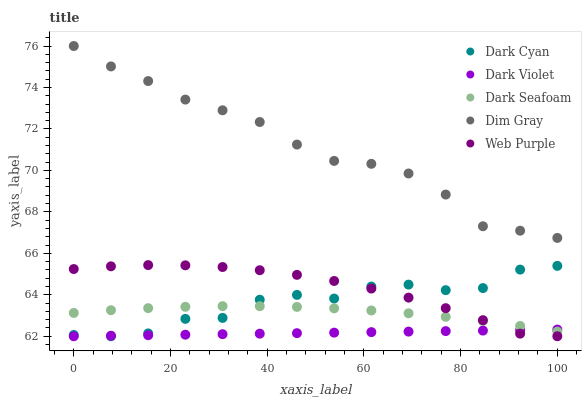Does Dark Violet have the minimum area under the curve?
Answer yes or no. Yes. Does Dim Gray have the maximum area under the curve?
Answer yes or no. Yes. Does Dark Seafoam have the minimum area under the curve?
Answer yes or no. No. Does Dark Seafoam have the maximum area under the curve?
Answer yes or no. No. Is Dark Violet the smoothest?
Answer yes or no. Yes. Is Dark Cyan the roughest?
Answer yes or no. Yes. Is Dark Seafoam the smoothest?
Answer yes or no. No. Is Dark Seafoam the roughest?
Answer yes or no. No. Does Dark Cyan have the lowest value?
Answer yes or no. Yes. Does Dark Seafoam have the lowest value?
Answer yes or no. No. Does Dim Gray have the highest value?
Answer yes or no. Yes. Does Dark Seafoam have the highest value?
Answer yes or no. No. Is Dark Cyan less than Dim Gray?
Answer yes or no. Yes. Is Dim Gray greater than Web Purple?
Answer yes or no. Yes. Does Dark Cyan intersect Web Purple?
Answer yes or no. Yes. Is Dark Cyan less than Web Purple?
Answer yes or no. No. Is Dark Cyan greater than Web Purple?
Answer yes or no. No. Does Dark Cyan intersect Dim Gray?
Answer yes or no. No. 